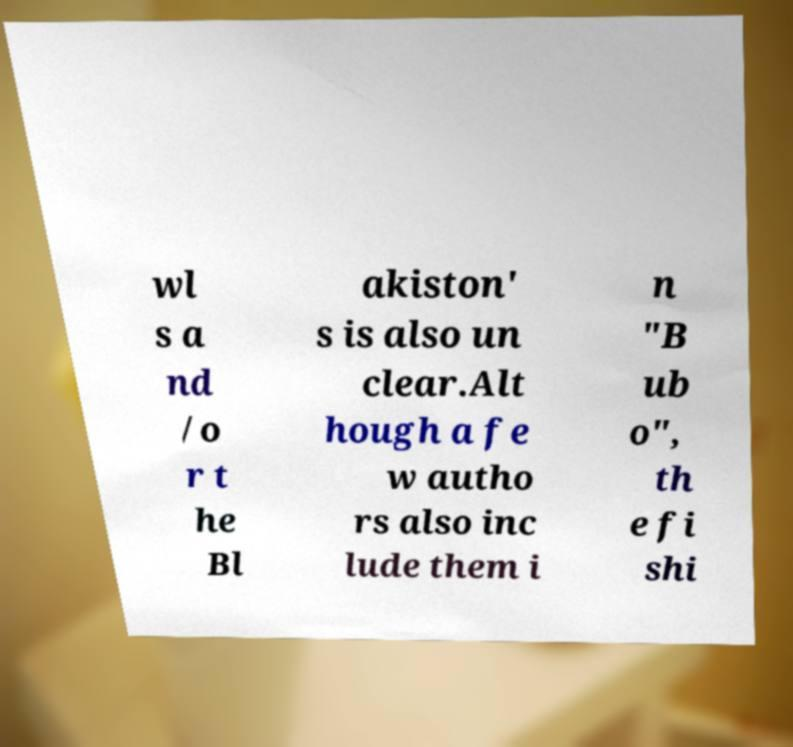Could you assist in decoding the text presented in this image and type it out clearly? wl s a nd /o r t he Bl akiston' s is also un clear.Alt hough a fe w autho rs also inc lude them i n "B ub o", th e fi shi 